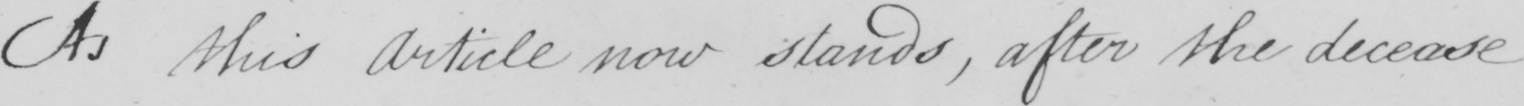Please provide the text content of this handwritten line. As this Article now stands , after the decease 